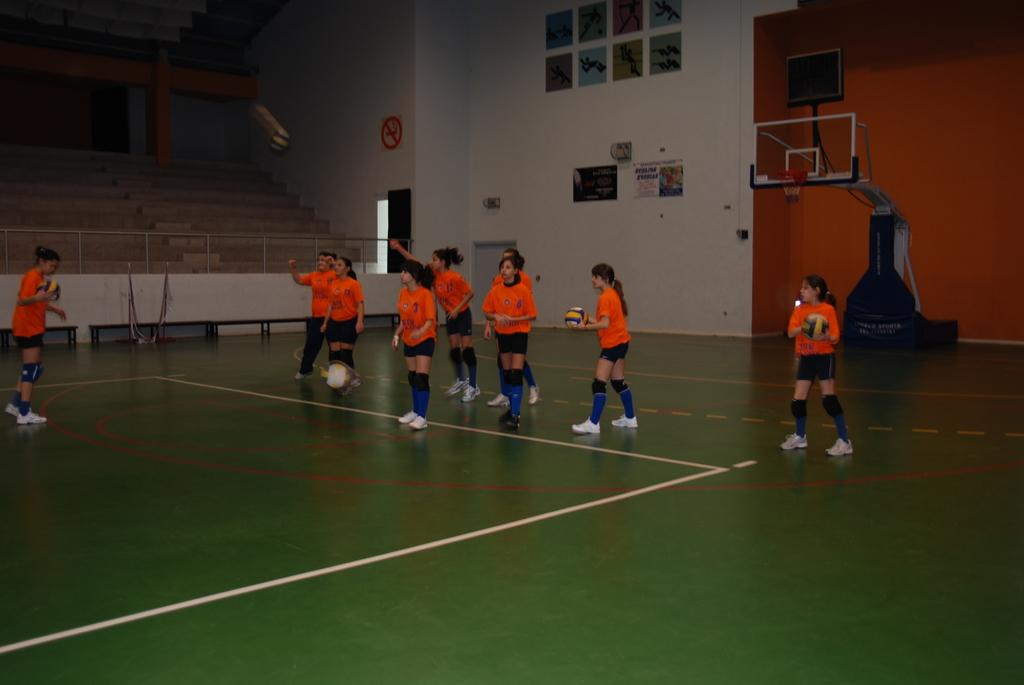What activity are the children engaged in within the image? The children are playing basketball in the image. What can be seen in the background of the image? There are benches in the background of the image. What color is the crayon being used by the children to draw on the basketball court? There is no crayon present in the image, and the children are playing basketball, not drawing. 